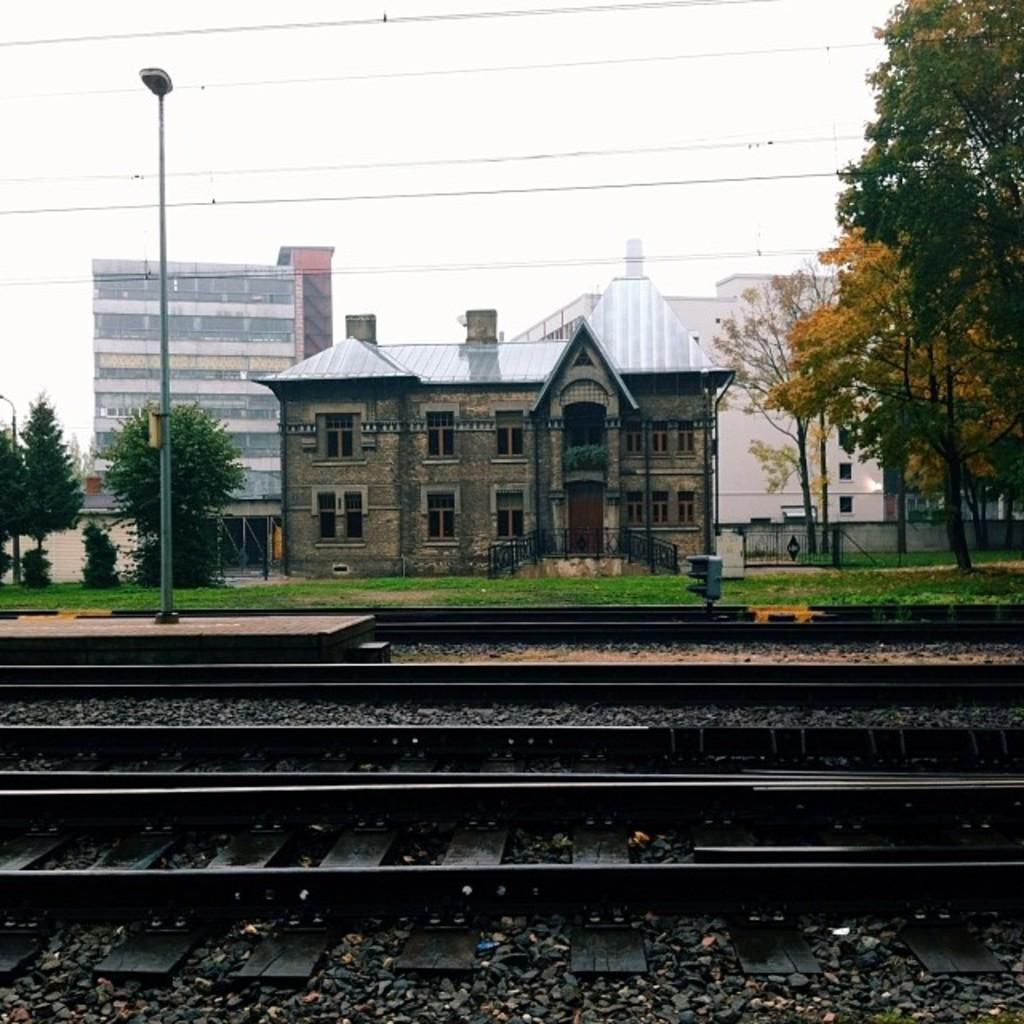What type of transportation infrastructure is present in the image? There are railway tracks in the image. What can be seen on the ground near the railway tracks? There are stones on the ground. What is the source of illumination in the image? There is a light pole in the image. What can be seen in the background of the image? There are trees and buildings with windows in the background of the image. What is visible in the sky in the image? The sky is visible in the image. How many ducks are sitting on the clover in the image? There are no ducks or clover present in the image. 